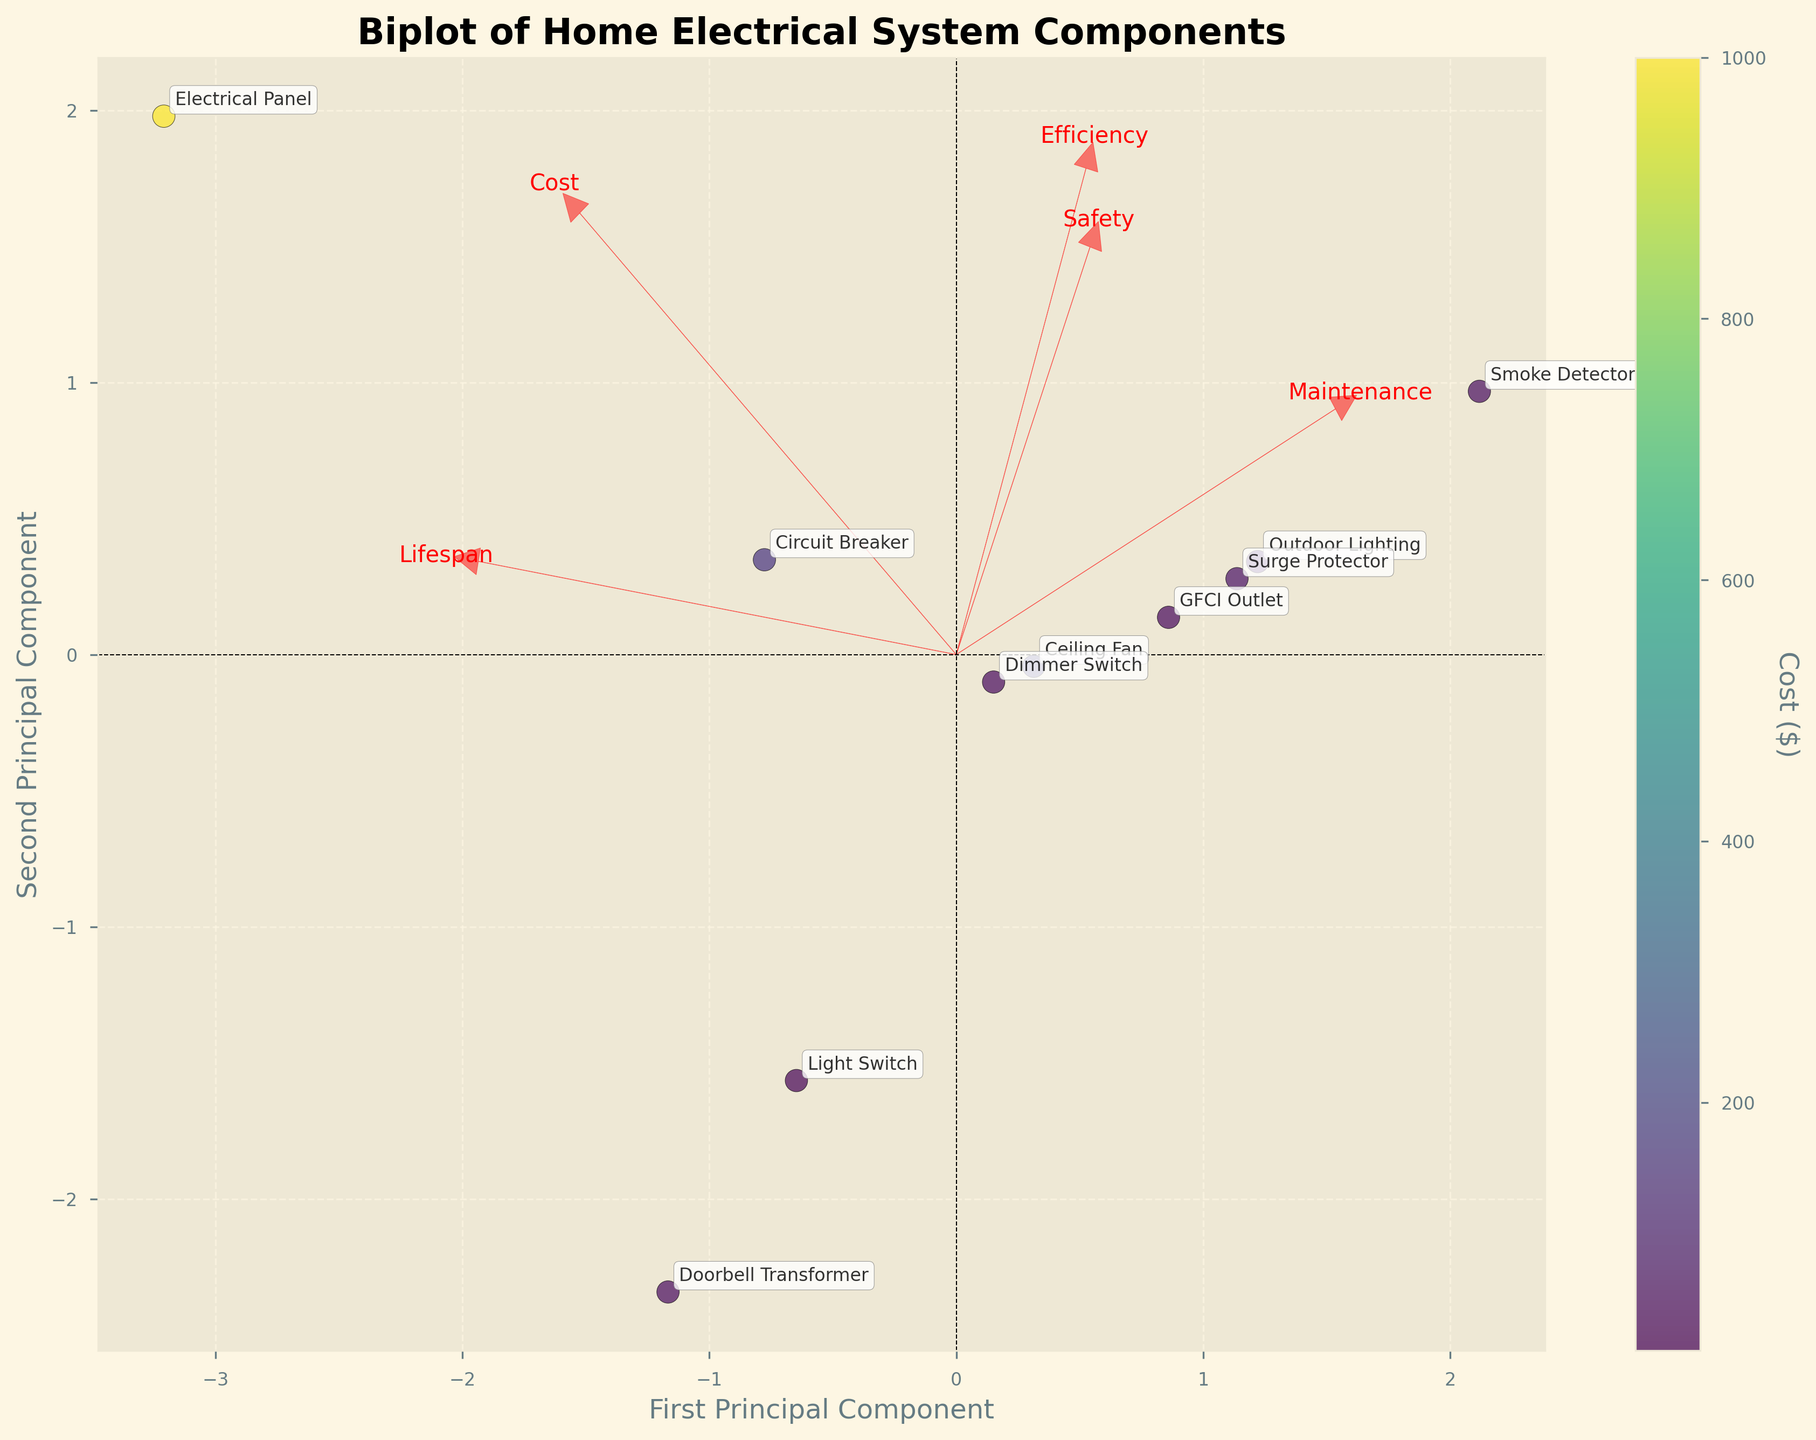How many components are plotted on the biplot? Count the number of labeled data points on the plot
Answer: 10 What is the title of the plot? The title is found at the top of the plot
Answer: Biplot of Home Electrical System Components Which component has the highest cost according to the color bar? Look for the data point with the darkest color corresponding to the highest value on the color bar
Answer: Electrical Panel Which component is positioned the farthest to the right on the first principal component axis? Identify the component that is located at the furthest position along the x-axis
Answer: Light Switch Which vector points both up and to the right and represents which feature? Check the vectors drawn from the origin to see which one points up and to the right, then read the label of that vector
Answer: Lifespan Which component has a higher maintenance frequency, GFCI Outlet or Surge Protector? Compare the positions on the plot and recall their respective maintenance frequencies
Answer: GFCI Outlet How do Safety Rating and Energy Efficiency relate in the biplot? Observe the direction of the vectors for Safety Rating and Energy Efficiency and determine their relative angle
Answer: They point in somewhat similar directions, indicating a possible positive correlation Identify the component with the shortest lifespan and describe its general position on the biplot. Shortest lifespan corresponds to the shortest numerical value; find its position on the plot
Answer: Surge Protector; it is found near the left side of the plot Which two features are most strongly correlated based on the vector directions? Look for vectors that are closest in direction
Answer: Safety (Safety Rating) and Cost 